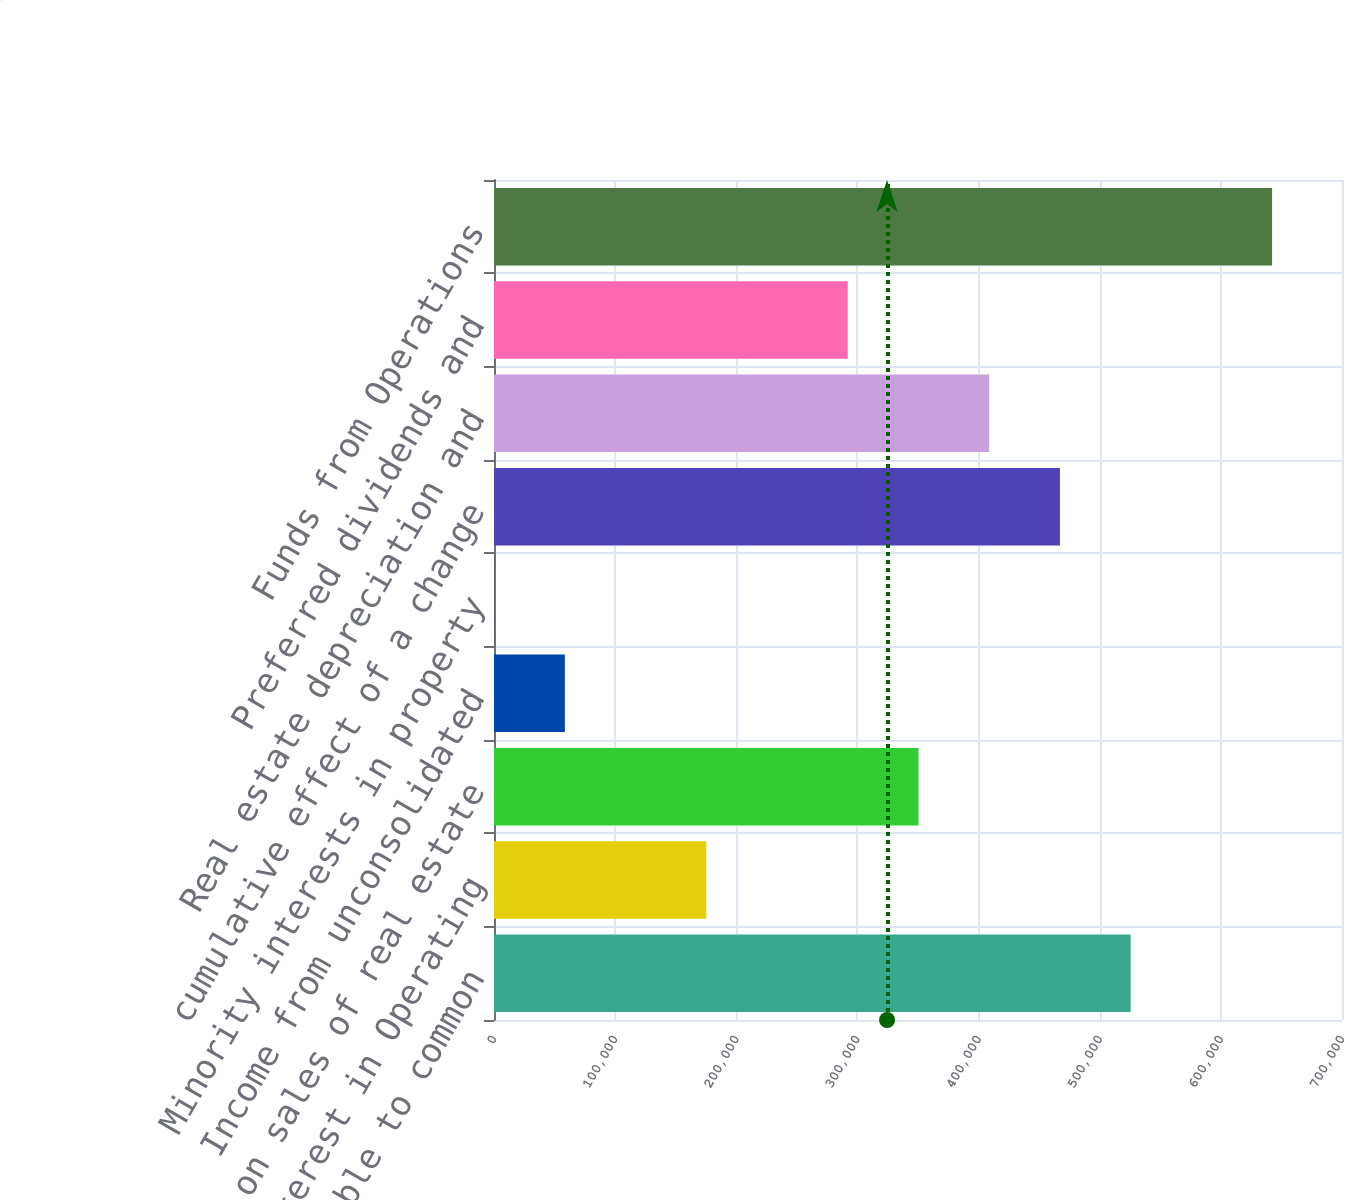<chart> <loc_0><loc_0><loc_500><loc_500><bar_chart><fcel>Net income available to common<fcel>Minority interest in Operating<fcel>Gains on sales of real estate<fcel>Income from unconsolidated<fcel>Minority interests in property<fcel>cumulative effect of a change<fcel>Real estate depreciation and<fcel>Preferred dividends and<fcel>Funds from Operations<nl><fcel>525538<fcel>175254<fcel>350396<fcel>58493.5<fcel>113<fcel>467157<fcel>408776<fcel>292016<fcel>642298<nl></chart> 